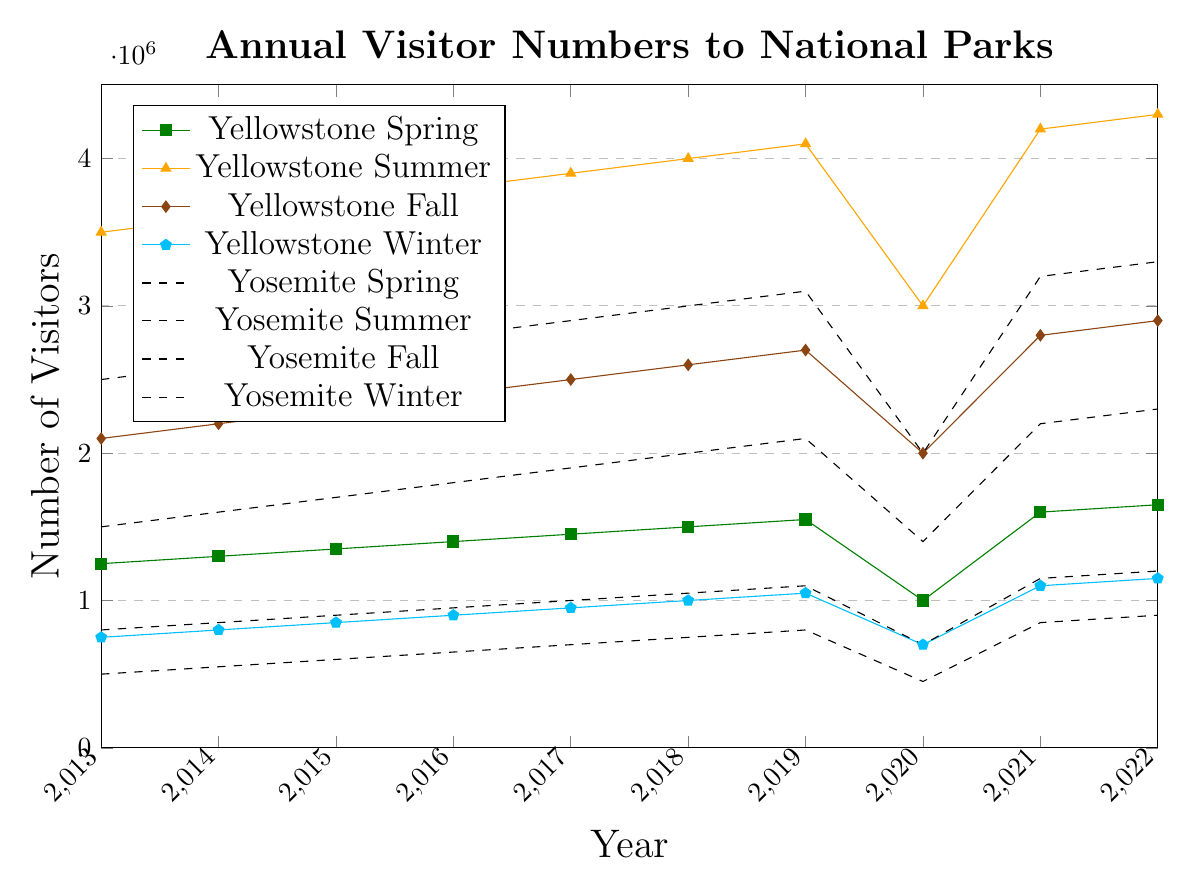What's the trend of visitor numbers to Yellowstone in the Summer from 2013 to 2022? To identify the trend, look at the visitor numbers for Yellowstone in summer each year from 2013 to 2022. The number increases consistently each year, with a notable drop in 2020.
Answer: Increasing Which park had more visitors in the Spring of 2020, Yellowstone or Yosemite? Compare the spring visitor numbers for 2020 for both parks. Yellowstone had 1,000,000 visitors, and Yosemite had 700,000.
Answer: Yellowstone What was the average number of visitors to Yosemite in Fall from 2013 to 2022? Sum the fall visitor numbers for Yosemite from 2013 to 2022 and divide by 10 (the number of years). (1,500,000 + 1,600,000 + 1,700,000 + 1,800,000 + 1,900,000 + 2,000,000 + 2,100,000 + 1,400,000 + 2,200,000 + 2,300,000) / 10 = 18,500,000 / 10.
Answer: 1,850,000 By how much did the number of visitors to Yellowstone in Winter increase from 2013 to 2022? Subtract the winter visitor number in 2013 from that in 2022 for Yellowstone. 1,150,000 - 750,000 = 400,000.
Answer: 400,000 Which season had the lowest visitor numbers for Yellowstone in 2020? Check the visitor numbers for each season for Yellowstone in 2020. Spring: 1,000,000, Summer: 3,000,000, Fall: 2,000,000, Winter: 700,000. Winter has the lowest.
Answer: Winter Visualize the difference in trends for summer visitors between Yellowstone and Yosemite from 2013 to 2022. Observe the summer visitor numbers. Both parks show an increasing trend from 2013 to 2022 with a dip in 2020. However, the scale of increase is different; Yellowstone has higher summer visitor numbers overall.
Answer: Both increase; Yellowstone has higher numbers How much greater were the total visitor numbers for Yosemite in 2019 compared to 2020? Sum the visitor numbers for all seasons in 2019 and 2020 for Yosemite and compare. 2019: 1,100,000 + 3,100,000 + 2,100,000 + 800,000 = 7,100,000. 2020: 700,000 + 2,000,000 + 1,400,000 + 450,000 = 4,550,000. The difference is 7,100,000 - 4,550,000 = 2,550,000.
Answer: 2,550,000 In which year did Yosemite see the highest Spring visitor numbers? Identify the year with the highest spring visitor number for Yosemite. 2022 shows the highest visitor number at 1,200,000.
Answer: 2022 Which season had the most significant drop in visitor numbers in 2020 for Yellowstone? Compare the visitor numbers of 2019 and 2020 for each season in Yellowstone and find the difference. Spring (15,50,00), Summer (11,000,000), Fall (7,00,000), Winter (3,50,000). Summer shows the largest drop.
Answer: Summer When did Yellowstone experience the highest number of visitors in Fall within the decade? Find the maximum fall visitor number for Yellowstone and the corresponding year from 2013 to 2022. The highest is 2,900,000 in 2022.
Answer: 2022 